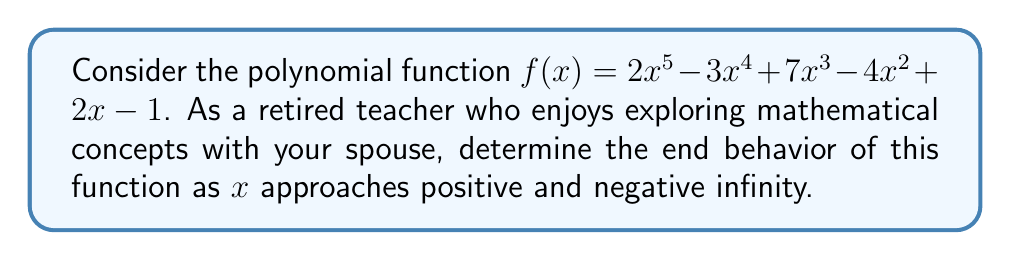Show me your answer to this math problem. To determine the end behavior of a polynomial function, we follow these steps:

1. Identify the leading term: 
   The leading term is the term with the highest degree. In this case, it's $2x^5$.

2. Determine the degree and leading coefficient:
   Degree: 5 (odd)
   Leading coefficient: 2 (positive)

3. Apply the end behavior rules:
   - For odd degree polynomials:
     - If the leading coefficient is positive, as $x \to +\infty$, $f(x) \to +\infty$, and as $x \to -\infty$, $f(x) \to -\infty$
     - If the leading coefficient is negative, the behavior is reversed

4. Conclude the end behavior:
   Since the degree is odd (5) and the leading coefficient is positive (2):
   - As $x \to +\infty$, $f(x) \to +\infty$
   - As $x \to -\infty$, $f(x) \to -\infty$

This means that for very large positive x-values, the function will increase without bound in the positive direction. For very large negative x-values, the function will decrease without bound in the negative direction.
Answer: As $x \to +\infty$, $f(x) \to +\infty$; as $x \to -\infty$, $f(x) \to -\infty$ 